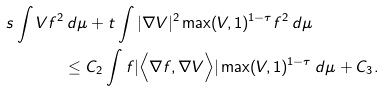<formula> <loc_0><loc_0><loc_500><loc_500>s \int V f ^ { 2 } & \, d \mu + t \int | \nabla V | ^ { 2 } \max ( V , 1 ) ^ { 1 - \tau } f ^ { 2 } \, d \mu \\ & \leq C _ { 2 } \int f | \Big < \nabla f , \nabla V \Big > | \max ( V , 1 ) ^ { 1 - \tau } \, d \mu + C _ { 3 } .</formula> 